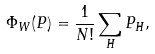<formula> <loc_0><loc_0><loc_500><loc_500>\Phi _ { W } ( P ) = \frac { 1 } { N ! } \sum _ { H } P _ { H } ,</formula> 